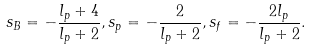Convert formula to latex. <formula><loc_0><loc_0><loc_500><loc_500>s _ { B } = - \frac { l _ { p } + 4 } { l _ { p } + 2 } , s _ { p } = - \frac { 2 } { l _ { p } + 2 } , s _ { f } = - \frac { 2 l _ { p } } { l _ { p } + 2 } .</formula> 